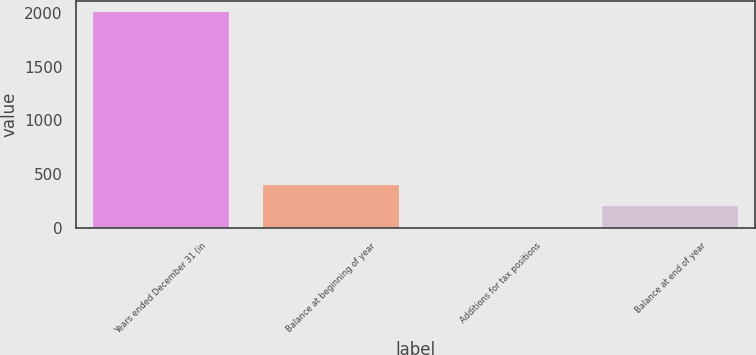Convert chart to OTSL. <chart><loc_0><loc_0><loc_500><loc_500><bar_chart><fcel>Years ended December 31 (in<fcel>Balance at beginning of year<fcel>Additions for tax positions<fcel>Balance at end of year<nl><fcel>2011<fcel>402.52<fcel>0.4<fcel>201.46<nl></chart> 